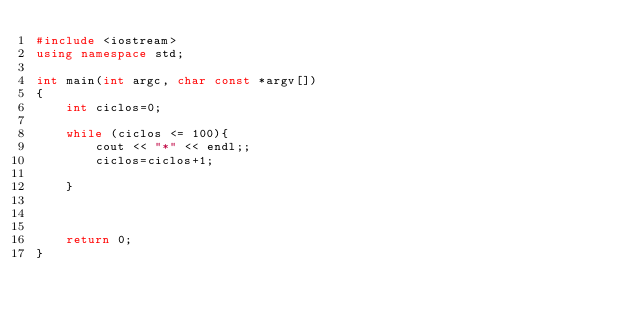<code> <loc_0><loc_0><loc_500><loc_500><_C++_>#include <iostream>
using namespace std;

int main(int argc, char const *argv[])
{
    int ciclos=0;

    while (ciclos <= 100){
        cout << "*" << endl;;
        ciclos=ciclos+1;

    }



    return 0;
}
</code> 